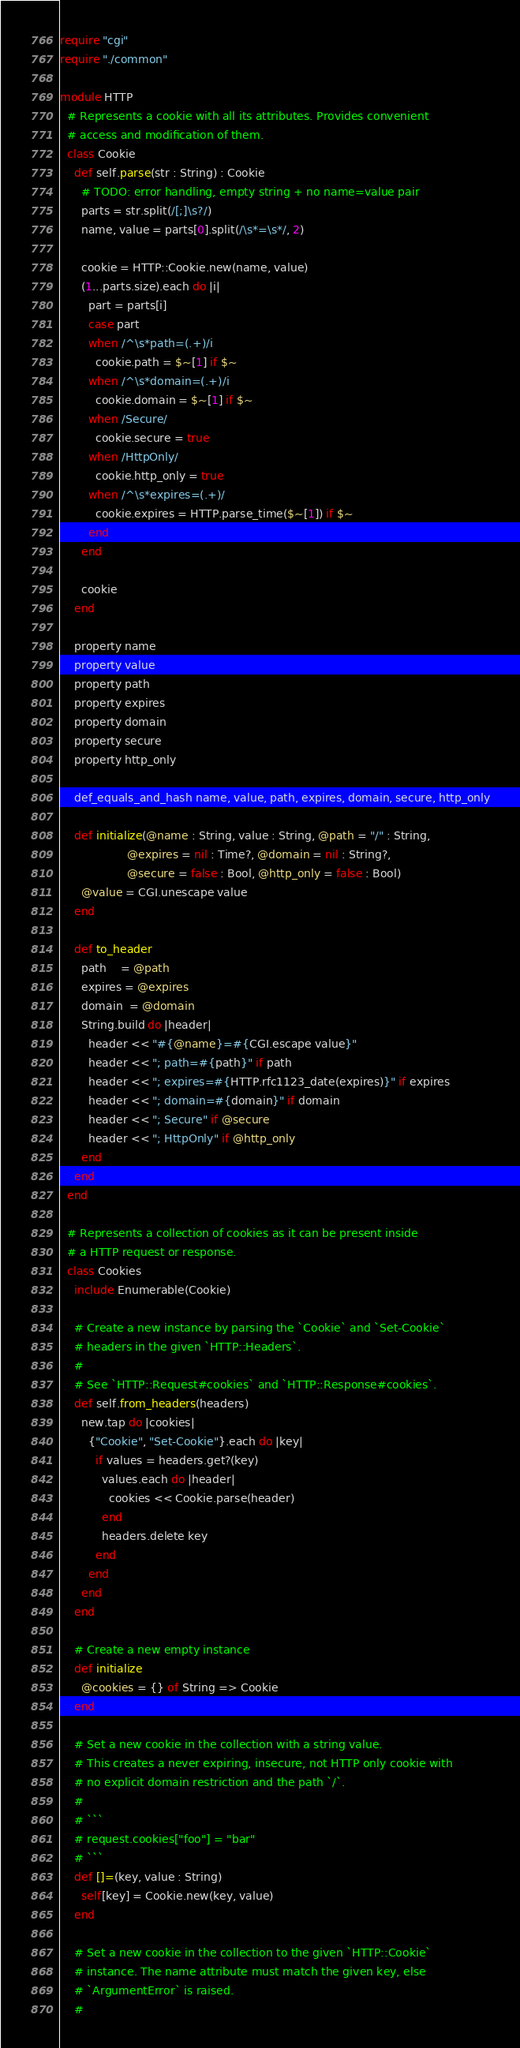Convert code to text. <code><loc_0><loc_0><loc_500><loc_500><_Crystal_>require "cgi"
require "./common"

module HTTP
  # Represents a cookie with all its attributes. Provides convenient
  # access and modification of them.
  class Cookie
    def self.parse(str : String) : Cookie
      # TODO: error handling, empty string + no name=value pair
      parts = str.split(/[;]\s?/)
      name, value = parts[0].split(/\s*=\s*/, 2)

      cookie = HTTP::Cookie.new(name, value)
      (1...parts.size).each do |i|
        part = parts[i]
        case part
        when /^\s*path=(.+)/i
          cookie.path = $~[1] if $~
        when /^\s*domain=(.+)/i
          cookie.domain = $~[1] if $~
        when /Secure/
          cookie.secure = true
        when /HttpOnly/
          cookie.http_only = true
        when /^\s*expires=(.+)/
          cookie.expires = HTTP.parse_time($~[1]) if $~
        end
      end

      cookie
    end

    property name
    property value
    property path
    property expires
    property domain
    property secure
    property http_only

    def_equals_and_hash name, value, path, expires, domain, secure, http_only

    def initialize(@name : String, value : String, @path = "/" : String,
                   @expires = nil : Time?, @domain = nil : String?,
                   @secure = false : Bool, @http_only = false : Bool)
      @value = CGI.unescape value
    end

    def to_header
      path    = @path
      expires = @expires
      domain  = @domain
      String.build do |header|
        header << "#{@name}=#{CGI.escape value}"
        header << "; path=#{path}" if path
        header << "; expires=#{HTTP.rfc1123_date(expires)}" if expires
        header << "; domain=#{domain}" if domain
        header << "; Secure" if @secure
        header << "; HttpOnly" if @http_only
      end
    end
  end

  # Represents a collection of cookies as it can be present inside
  # a HTTP request or response.
  class Cookies
    include Enumerable(Cookie)

    # Create a new instance by parsing the `Cookie` and `Set-Cookie`
    # headers in the given `HTTP::Headers`.
    #
    # See `HTTP::Request#cookies` and `HTTP::Response#cookies`.
    def self.from_headers(headers)
      new.tap do |cookies|
        {"Cookie", "Set-Cookie"}.each do |key|
          if values = headers.get?(key)
            values.each do |header|
              cookies << Cookie.parse(header)
            end
            headers.delete key
          end
        end
      end
    end

    # Create a new empty instance
    def initialize
      @cookies = {} of String => Cookie
    end

    # Set a new cookie in the collection with a string value.
    # This creates a never expiring, insecure, not HTTP only cookie with
    # no explicit domain restriction and the path `/`.
    #
    # ```
    # request.cookies["foo"] = "bar"
    # ```
    def []=(key, value : String)
      self[key] = Cookie.new(key, value)
    end

    # Set a new cookie in the collection to the given `HTTP::Cookie`
    # instance. The name attribute must match the given key, else
    # `ArgumentError` is raised.
    #</code> 